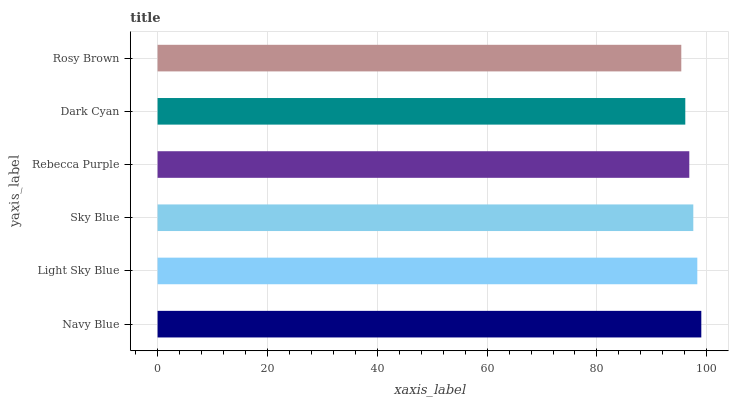Is Rosy Brown the minimum?
Answer yes or no. Yes. Is Navy Blue the maximum?
Answer yes or no. Yes. Is Light Sky Blue the minimum?
Answer yes or no. No. Is Light Sky Blue the maximum?
Answer yes or no. No. Is Navy Blue greater than Light Sky Blue?
Answer yes or no. Yes. Is Light Sky Blue less than Navy Blue?
Answer yes or no. Yes. Is Light Sky Blue greater than Navy Blue?
Answer yes or no. No. Is Navy Blue less than Light Sky Blue?
Answer yes or no. No. Is Sky Blue the high median?
Answer yes or no. Yes. Is Rebecca Purple the low median?
Answer yes or no. Yes. Is Navy Blue the high median?
Answer yes or no. No. Is Light Sky Blue the low median?
Answer yes or no. No. 